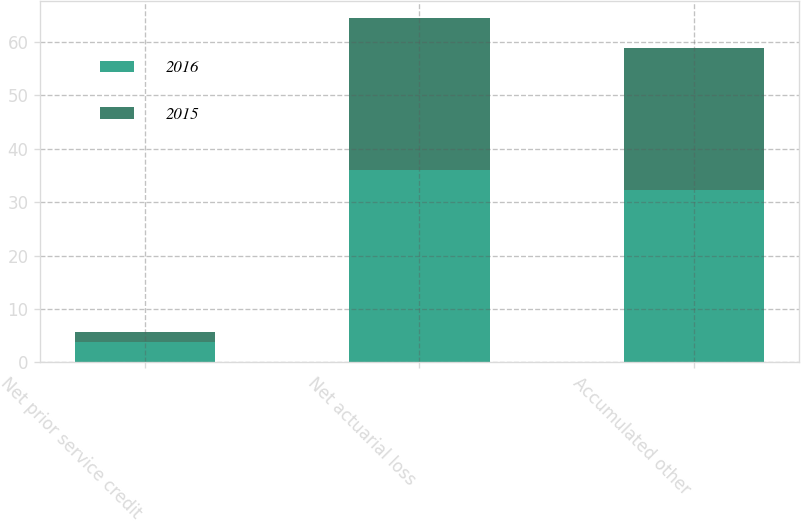<chart> <loc_0><loc_0><loc_500><loc_500><stacked_bar_chart><ecel><fcel>Net prior service credit<fcel>Net actuarial loss<fcel>Accumulated other<nl><fcel>2016<fcel>3.9<fcel>36.1<fcel>32.2<nl><fcel>2015<fcel>1.8<fcel>28.4<fcel>26.6<nl></chart> 